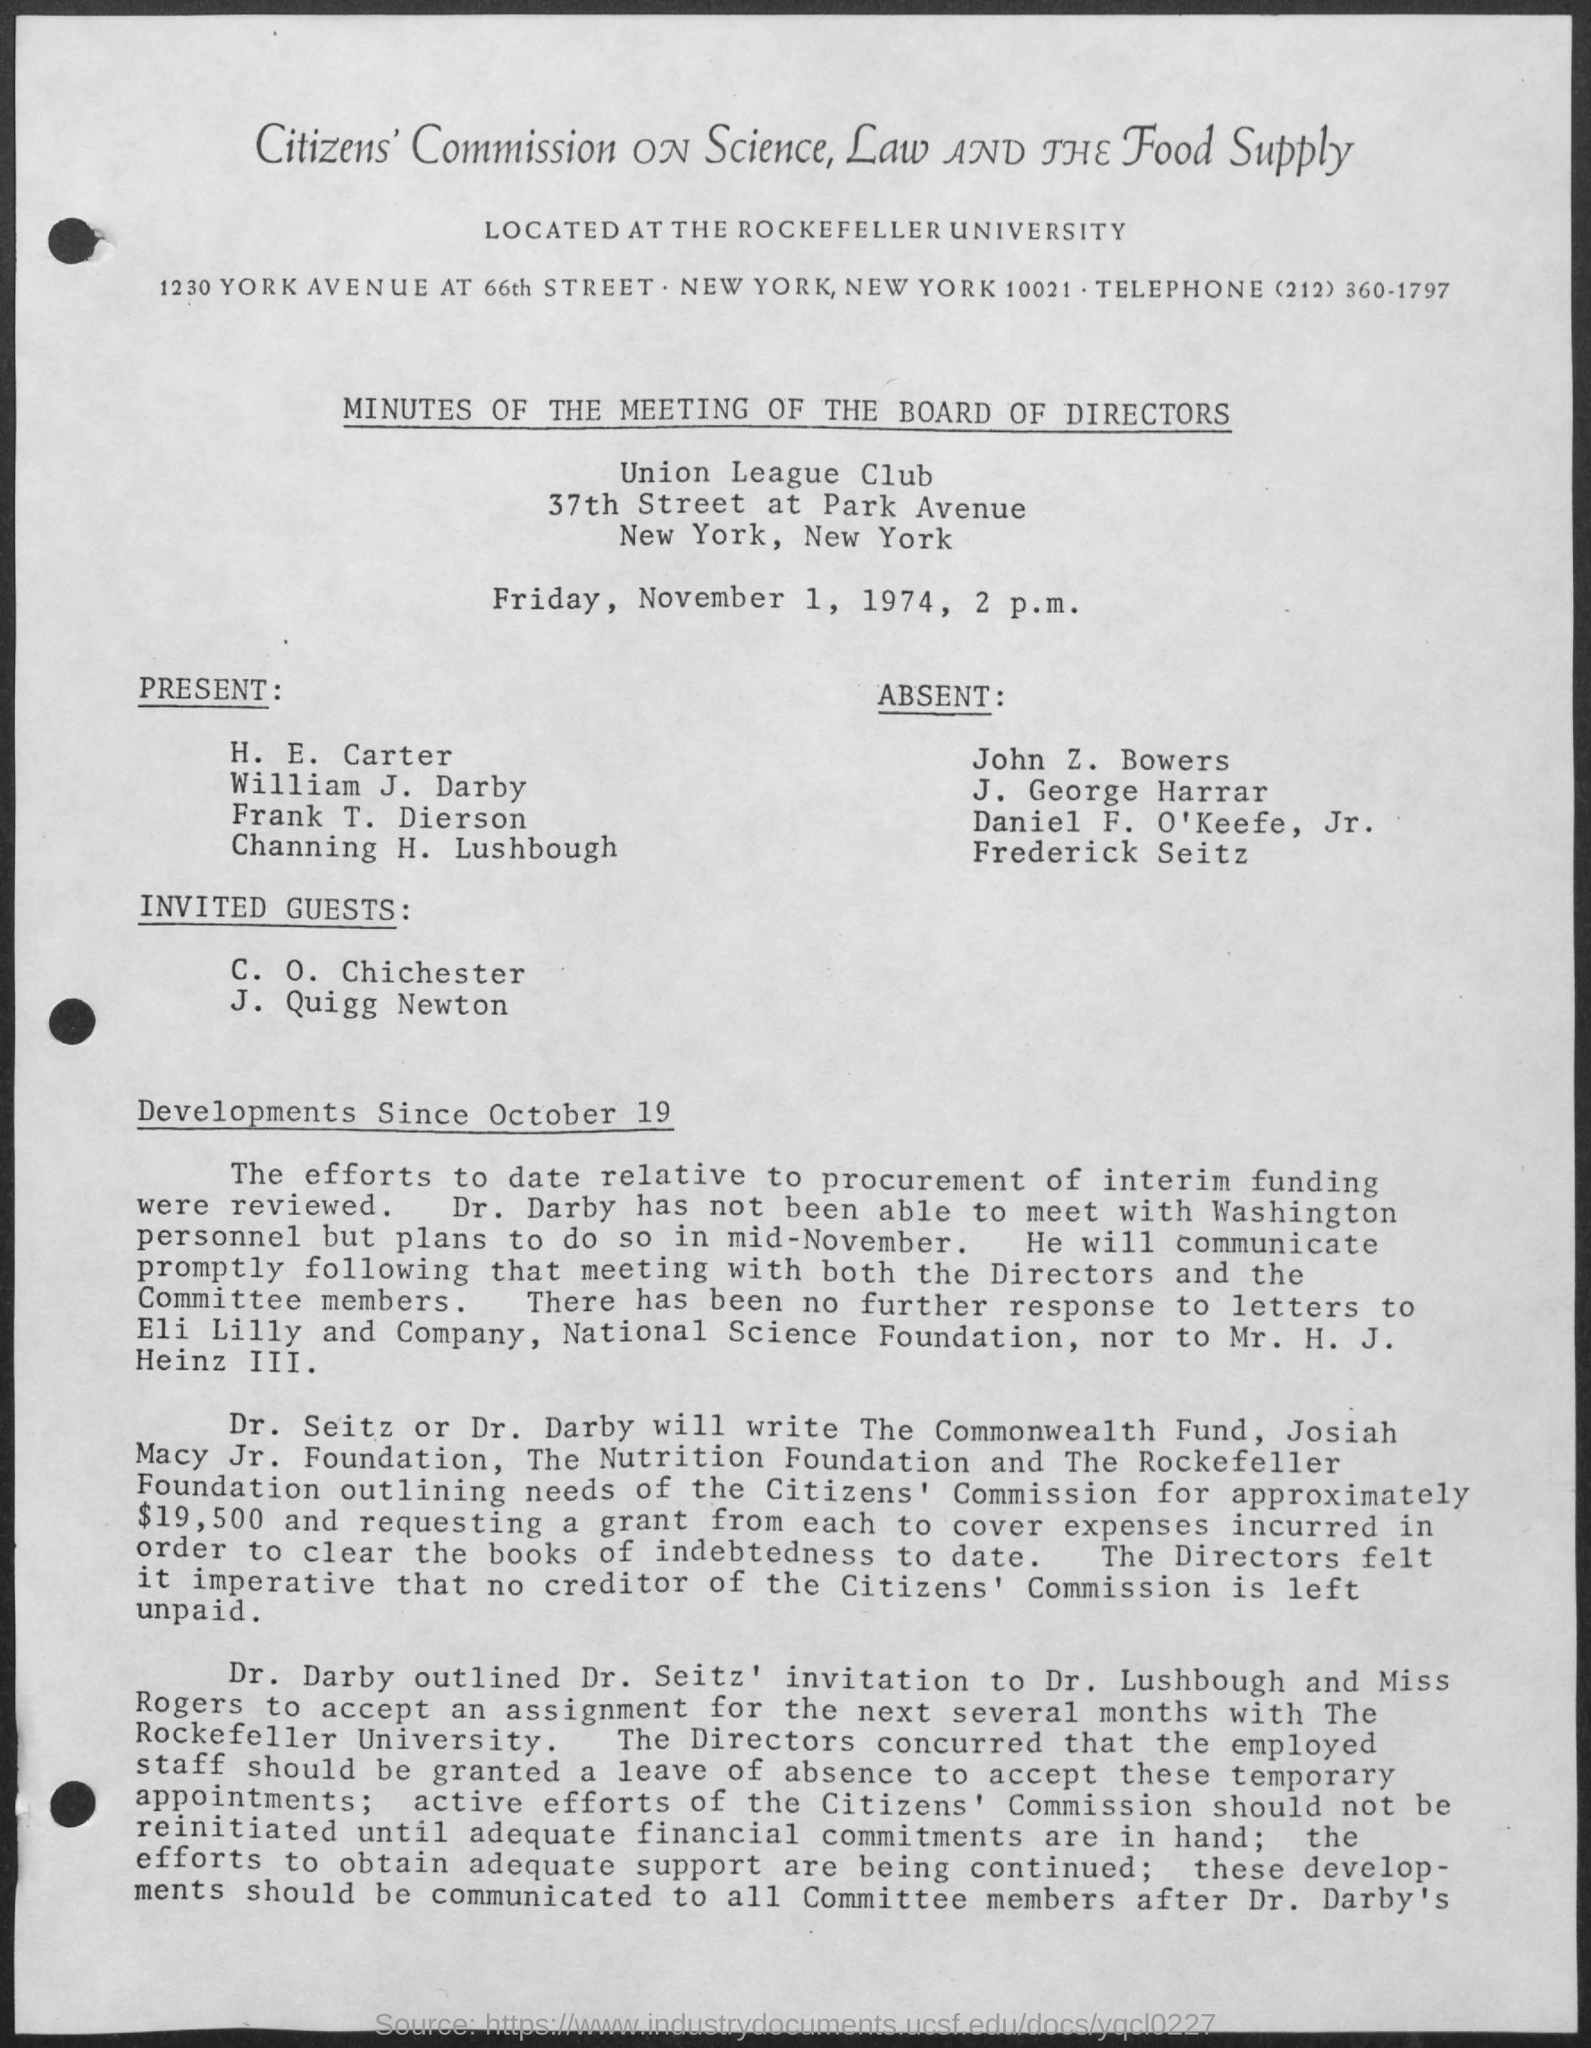Draw attention to some important aspects in this diagram. The Union League Club is the name of the club mentioned in the given page. The date mentioned in the given page is Friday, November 1, 1974. The meeting was conducted at 2 p.m. 